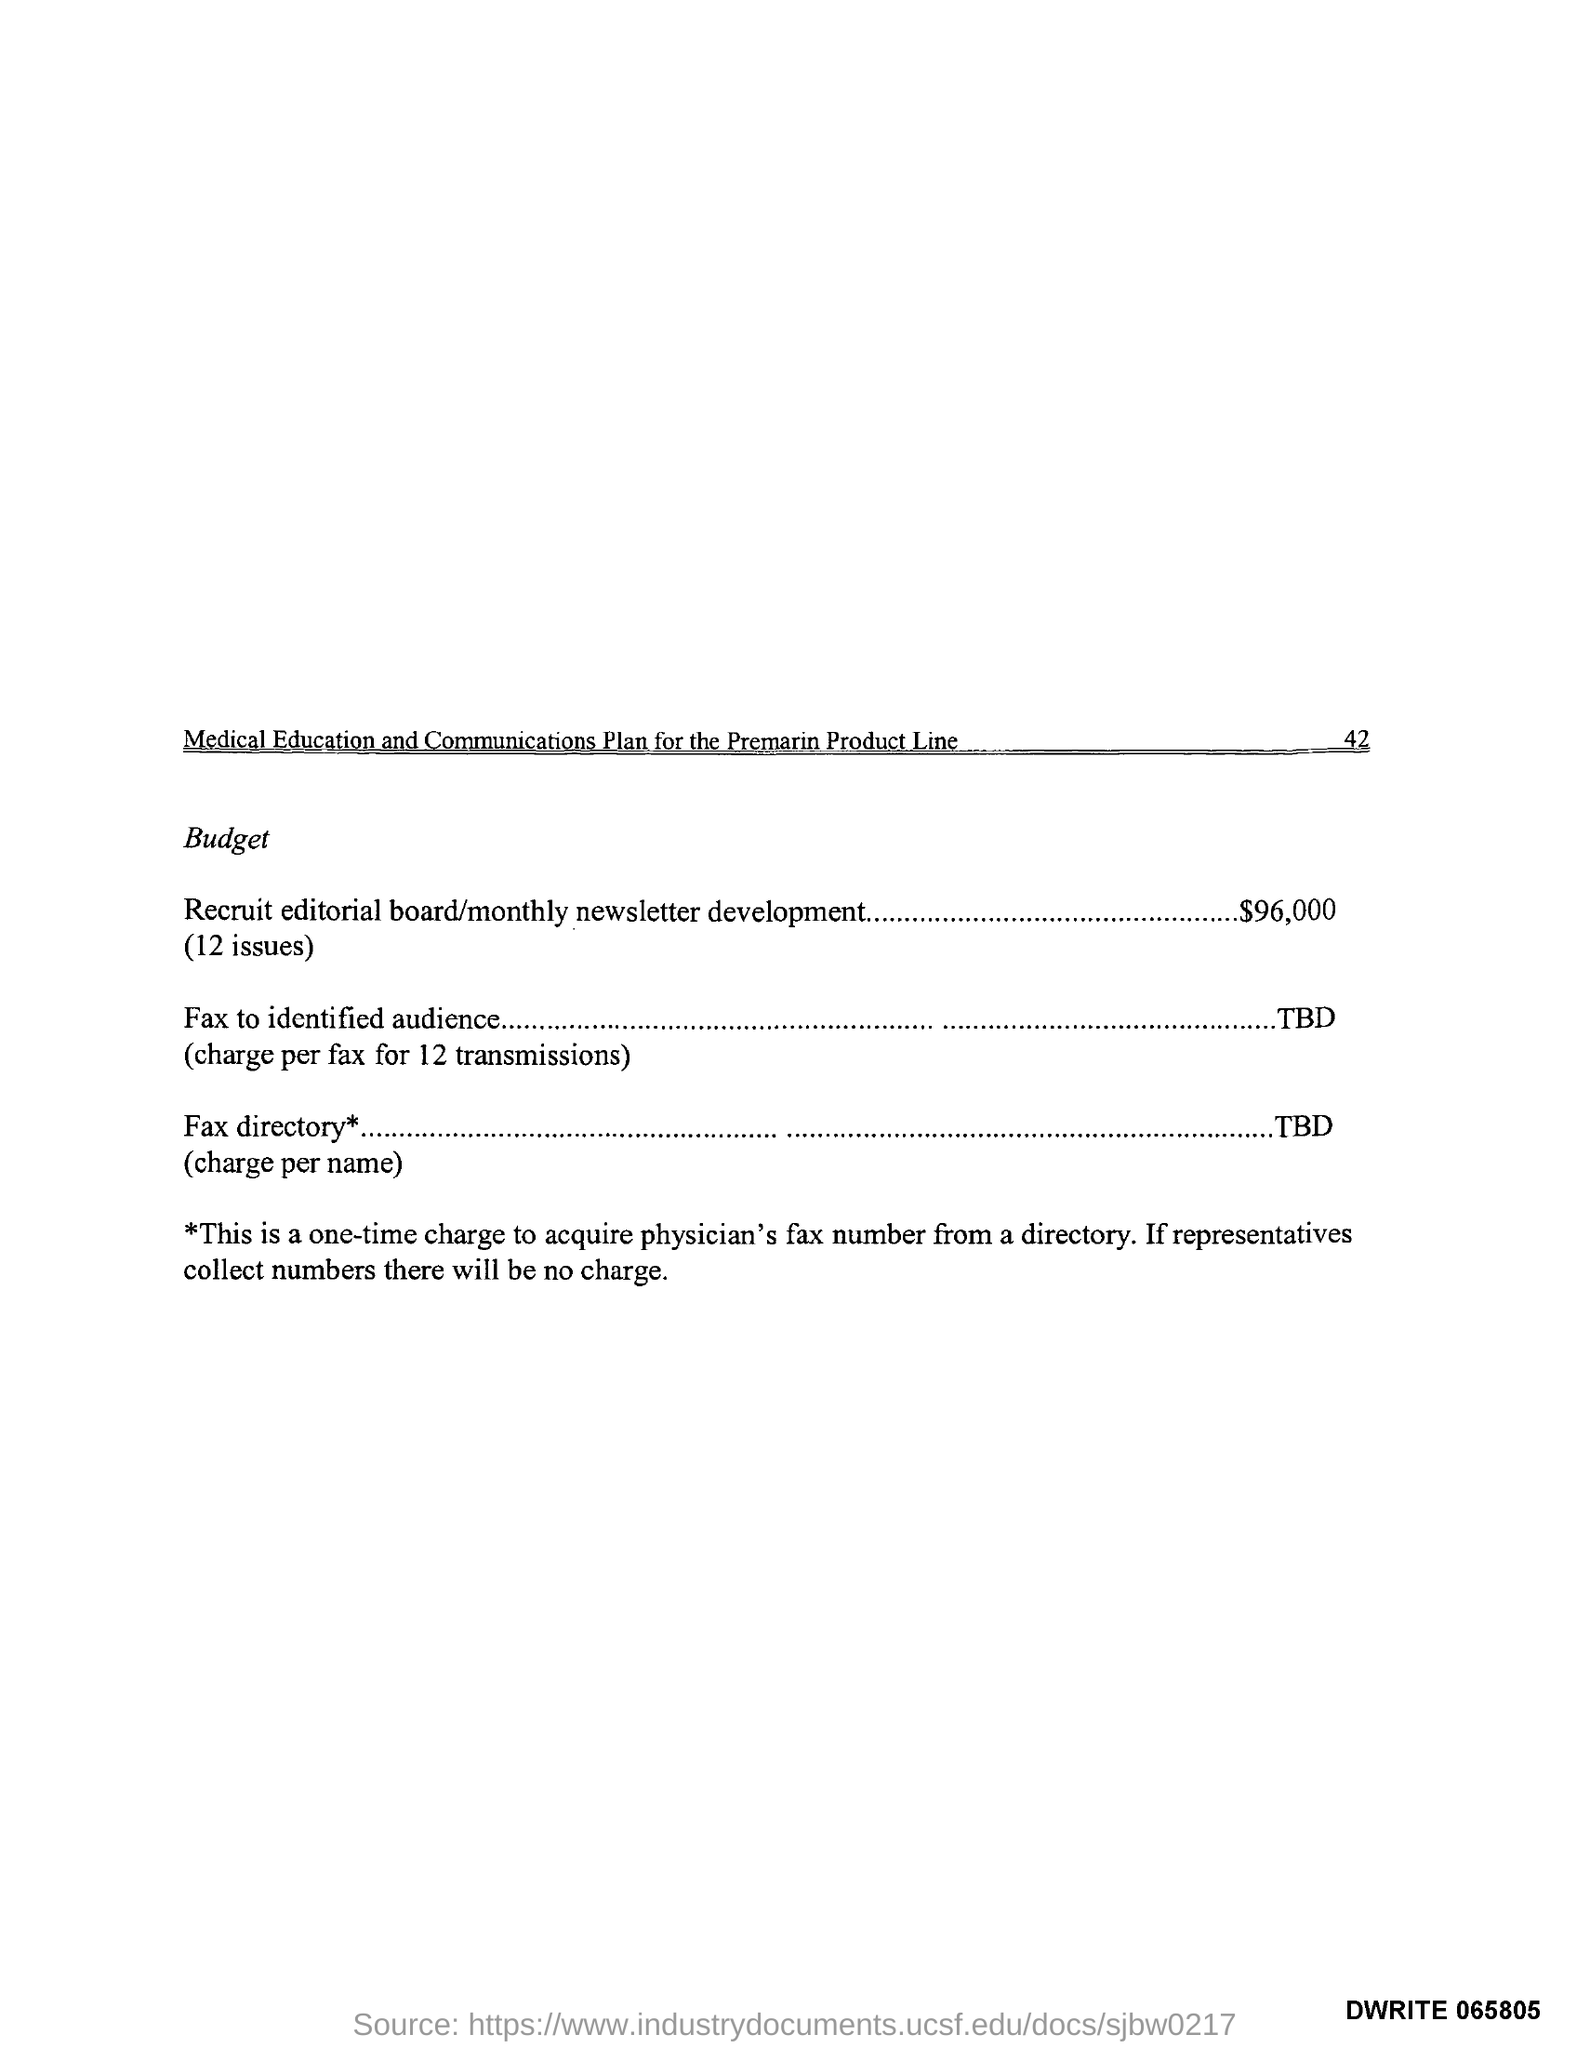Specify some key components in this picture. The page number of "Medical Education and Communication Plan for the Premarian Product Line" is 42. 